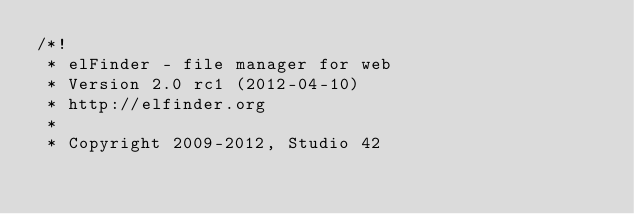Convert code to text. <code><loc_0><loc_0><loc_500><loc_500><_CSS_>/*!
 * elFinder - file manager for web
 * Version 2.0 rc1 (2012-04-10)
 * http://elfinder.org
 * 
 * Copyright 2009-2012, Studio 42</code> 